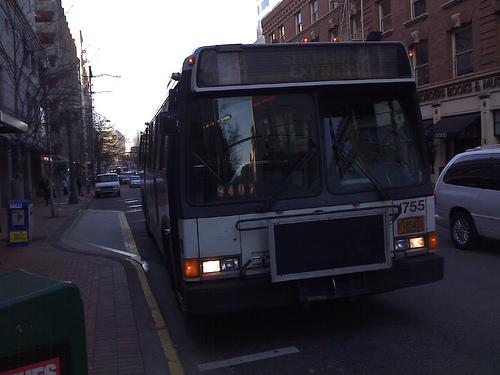What is the bus next to? Please explain your reasoning. curb. The side of the road has some stores in front. 